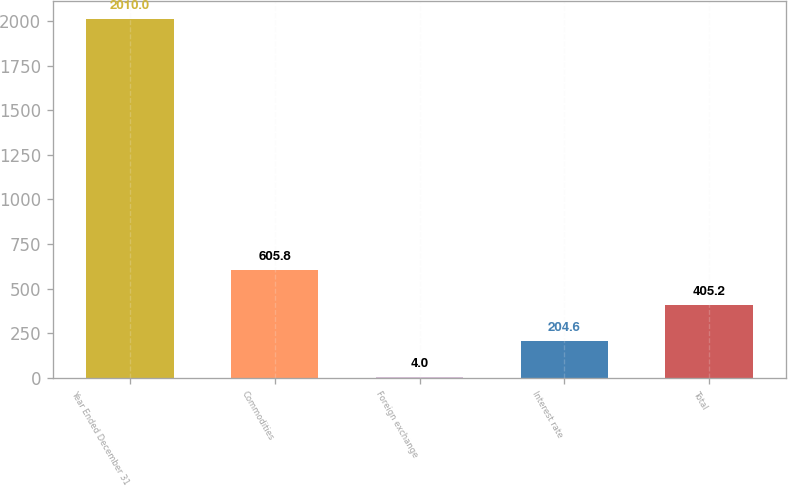Convert chart to OTSL. <chart><loc_0><loc_0><loc_500><loc_500><bar_chart><fcel>Year Ended December 31<fcel>Commodities<fcel>Foreign exchange<fcel>Interest rate<fcel>Total<nl><fcel>2010<fcel>605.8<fcel>4<fcel>204.6<fcel>405.2<nl></chart> 